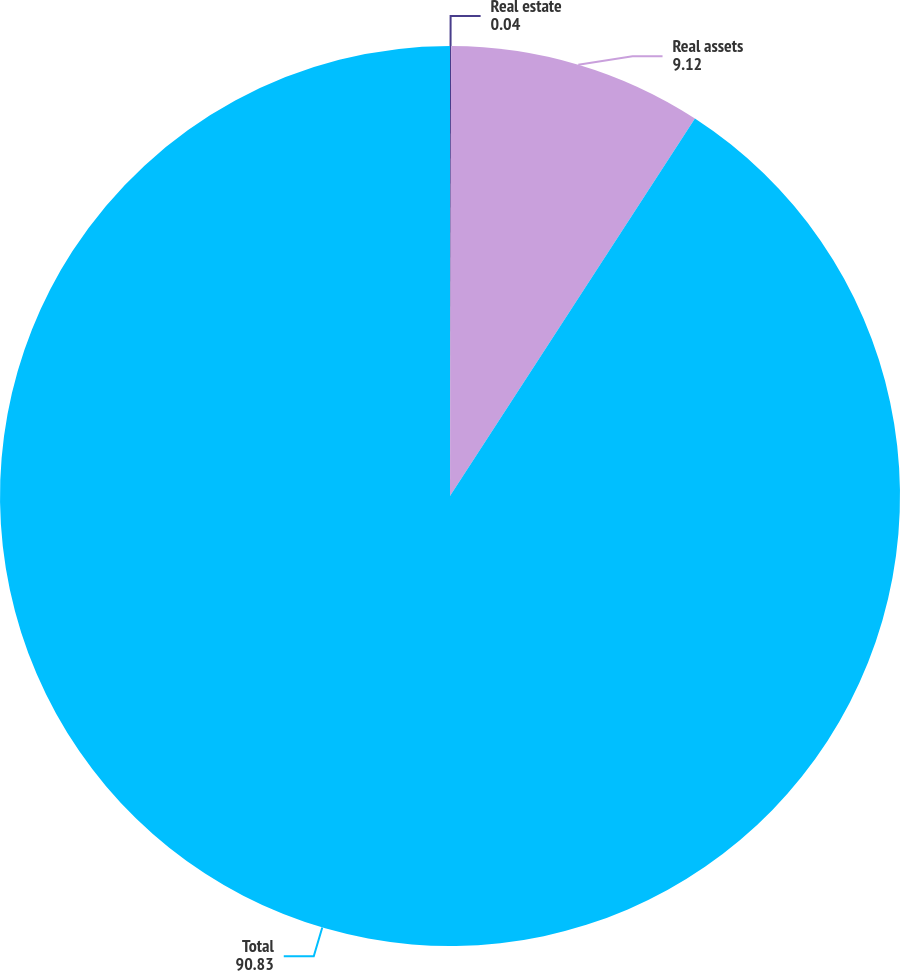Convert chart. <chart><loc_0><loc_0><loc_500><loc_500><pie_chart><fcel>Real estate<fcel>Real assets<fcel>Total<nl><fcel>0.04%<fcel>9.12%<fcel>90.83%<nl></chart> 